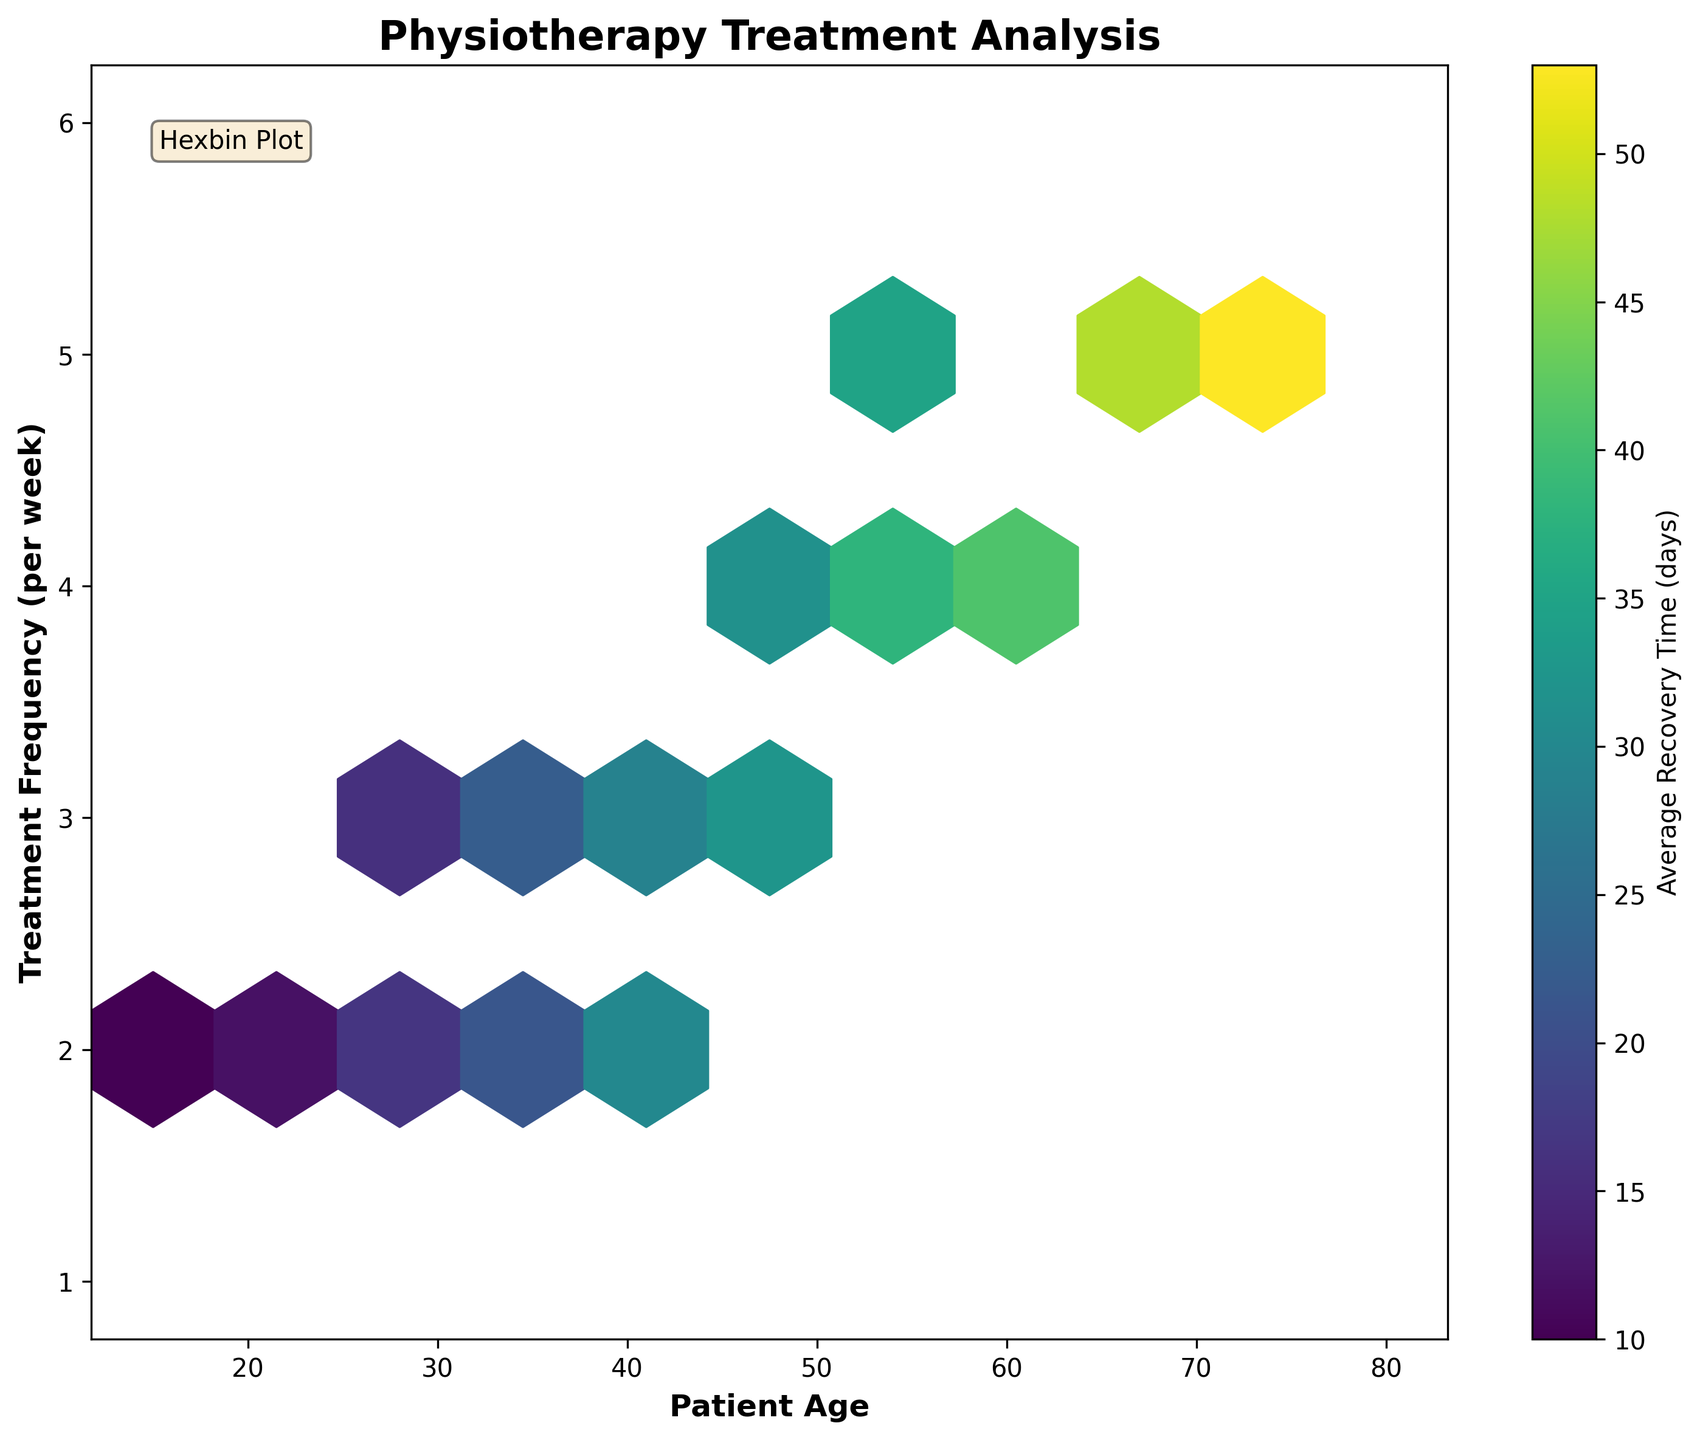What is the title of the plot? The plot's title can be found at the top of the figure. It reads "Physiotherapy Treatment Analysis."
Answer: Physiotherapy Treatment Analysis What does the color in the hexagons represent? According to the color bar on the right side of the plot, the colors represent the average recovery time in days.
Answer: Average Recovery Time (days) What is the x-axis labeled? The label of the x-axis is located at the bottom of the plot and reads "Patient Age."
Answer: Patient Age What is the y-axis labeled? The label of the y-axis is located on the left side of the plot and reads "Treatment Frequency (per week)."
Answer: Treatment Frequency (per week) How many hexagons are mostly dark purple? Dark purple hexagons indicate areas with the highest average recovery time values based on the color legend. There are two dark purple hexagons in the plot.
Answer: Two What is the general trend regarding patient age and treatment frequency? By looking at the distribution, it appears that older patients tend to have higher treatment frequencies. This is deduced by the placement of higher frequency hexagons towards the higher end of the age spectrum.
Answer: Older patients tend to have higher treatment frequencies Which age group has the most variation in treatment frequency? The plot uses hexagons of different sizes to indicate variation. Ages around 35-50 seem to have more hexagons covering multiple treatment frequencies, suggesting higher variation.
Answer: Ages 35-50 Is there a visible relationship between treatment frequency and recovery time? By examining the different colors of hexagons at different frequencies, generally, it looks like higher treatment frequencies correlate with longer recovery times. This is based on noticing more darker colors at higher treatment frequencies.
Answer: Higher treatment frequencies typically correlate with longer recovery times What is the average recovery time for patients in their 60s receiving 4 treatments per week? Find the hexagons that represent patients in their 60s (x-axis) receiving 4 treatments per week (y-axis). From the color, it appears yellow, which is around the middle of the color bar, indicating approximately 40 days.
Answer: Approximately 40 days Which age group has the quickest recovery in the plot? Hexagons on the lower end of the color bar represent quicker recoveries (lighter colors). Patients in their 20s receiving 2 treatments per week show the lightest color, indicating the quickest recovery.
Answer: Patients in their 20s with 2 treatments per week 